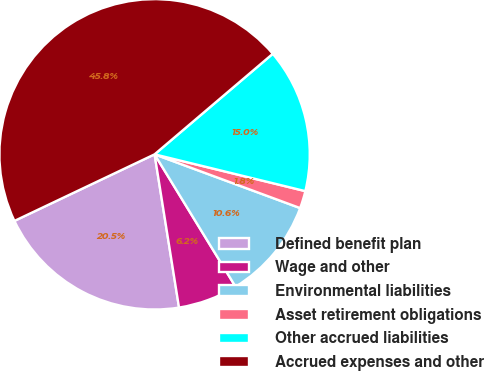Convert chart. <chart><loc_0><loc_0><loc_500><loc_500><pie_chart><fcel>Defined benefit plan<fcel>Wage and other<fcel>Environmental liabilities<fcel>Asset retirement obligations<fcel>Other accrued liabilities<fcel>Accrued expenses and other<nl><fcel>20.46%<fcel>6.22%<fcel>10.63%<fcel>1.82%<fcel>15.03%<fcel>45.84%<nl></chart> 